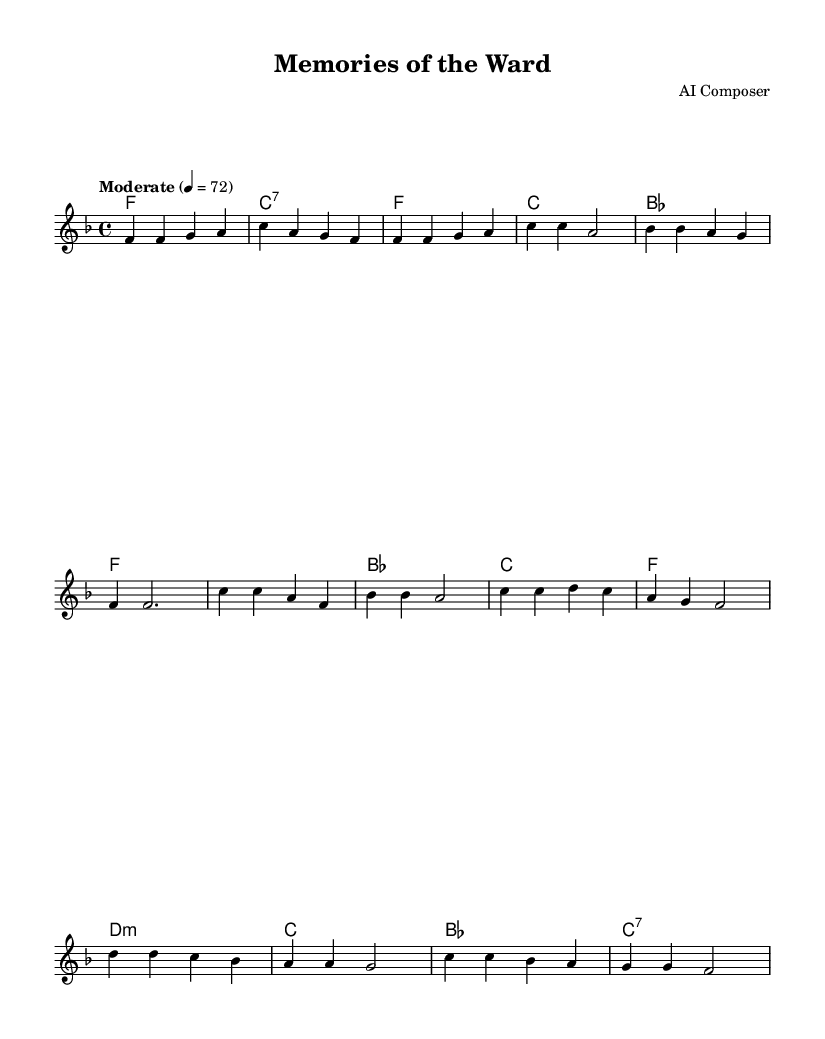What is the key signature of this music? The key signature is indicated by the number of sharps or flats at the beginning of the staff. In this score, there are no sharps or flats shown, which means it has a key signature of F major.
Answer: F major What is the time signature of this music? The time signature appears at the beginning of the music. Here, it is represented by "4/4," which means there are four beats in each measure and the quarter note gets the beat.
Answer: 4/4 What is the tempo marking in this music? The tempo marking describes the speed of the music, typically indicated above the staff. In this case, the marking is "Moderate" with a metronome indication of 72 beats per minute.
Answer: Moderate How many measures are in the melody section? To determine the number of measures, we can count the groups of notes that are separated by vertical bar lines in the melody part. There are a total of eight measures identified in the melody section.
Answer: Eight What is the first chord of the harmony section? The first chord is found in the harmony part, specifically where the first chord symbol is indicated. Here, the first chord symbol is "f1," indicating the F major chord.
Answer: F Which section features a bridge? The bridge section can be determined by identifying the labeled part of the music. In this score, the bridge is clearly labeled and occurs after the chorus, indicating it provides a contrast in the piece.
Answer: Bridge 